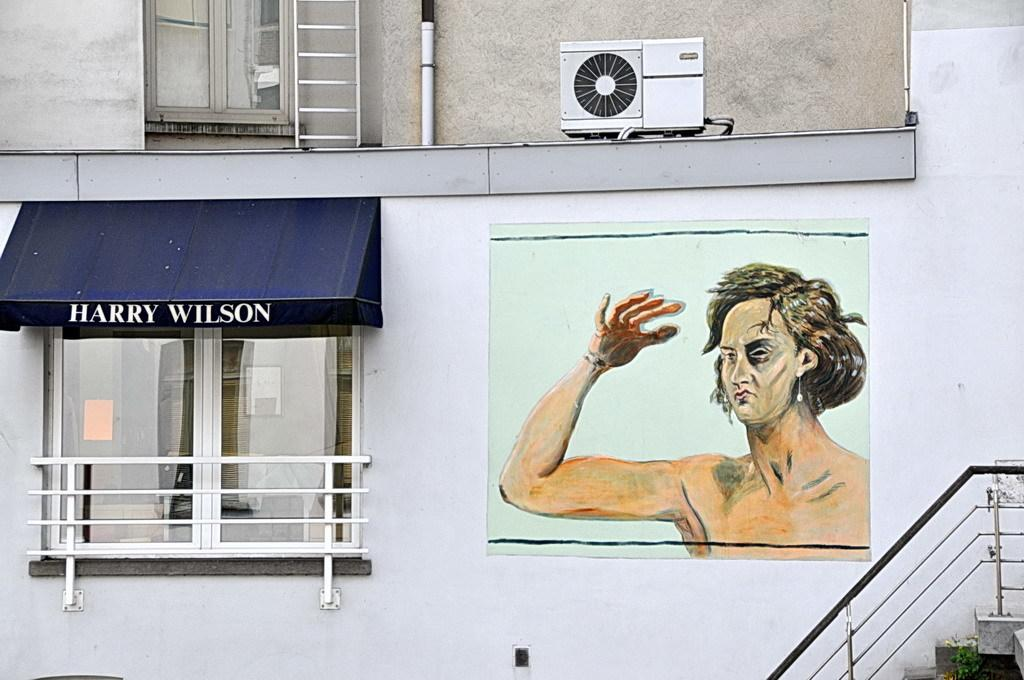<image>
Give a short and clear explanation of the subsequent image. A blue awning with the words Harry Wilson looks over a small balcony. 